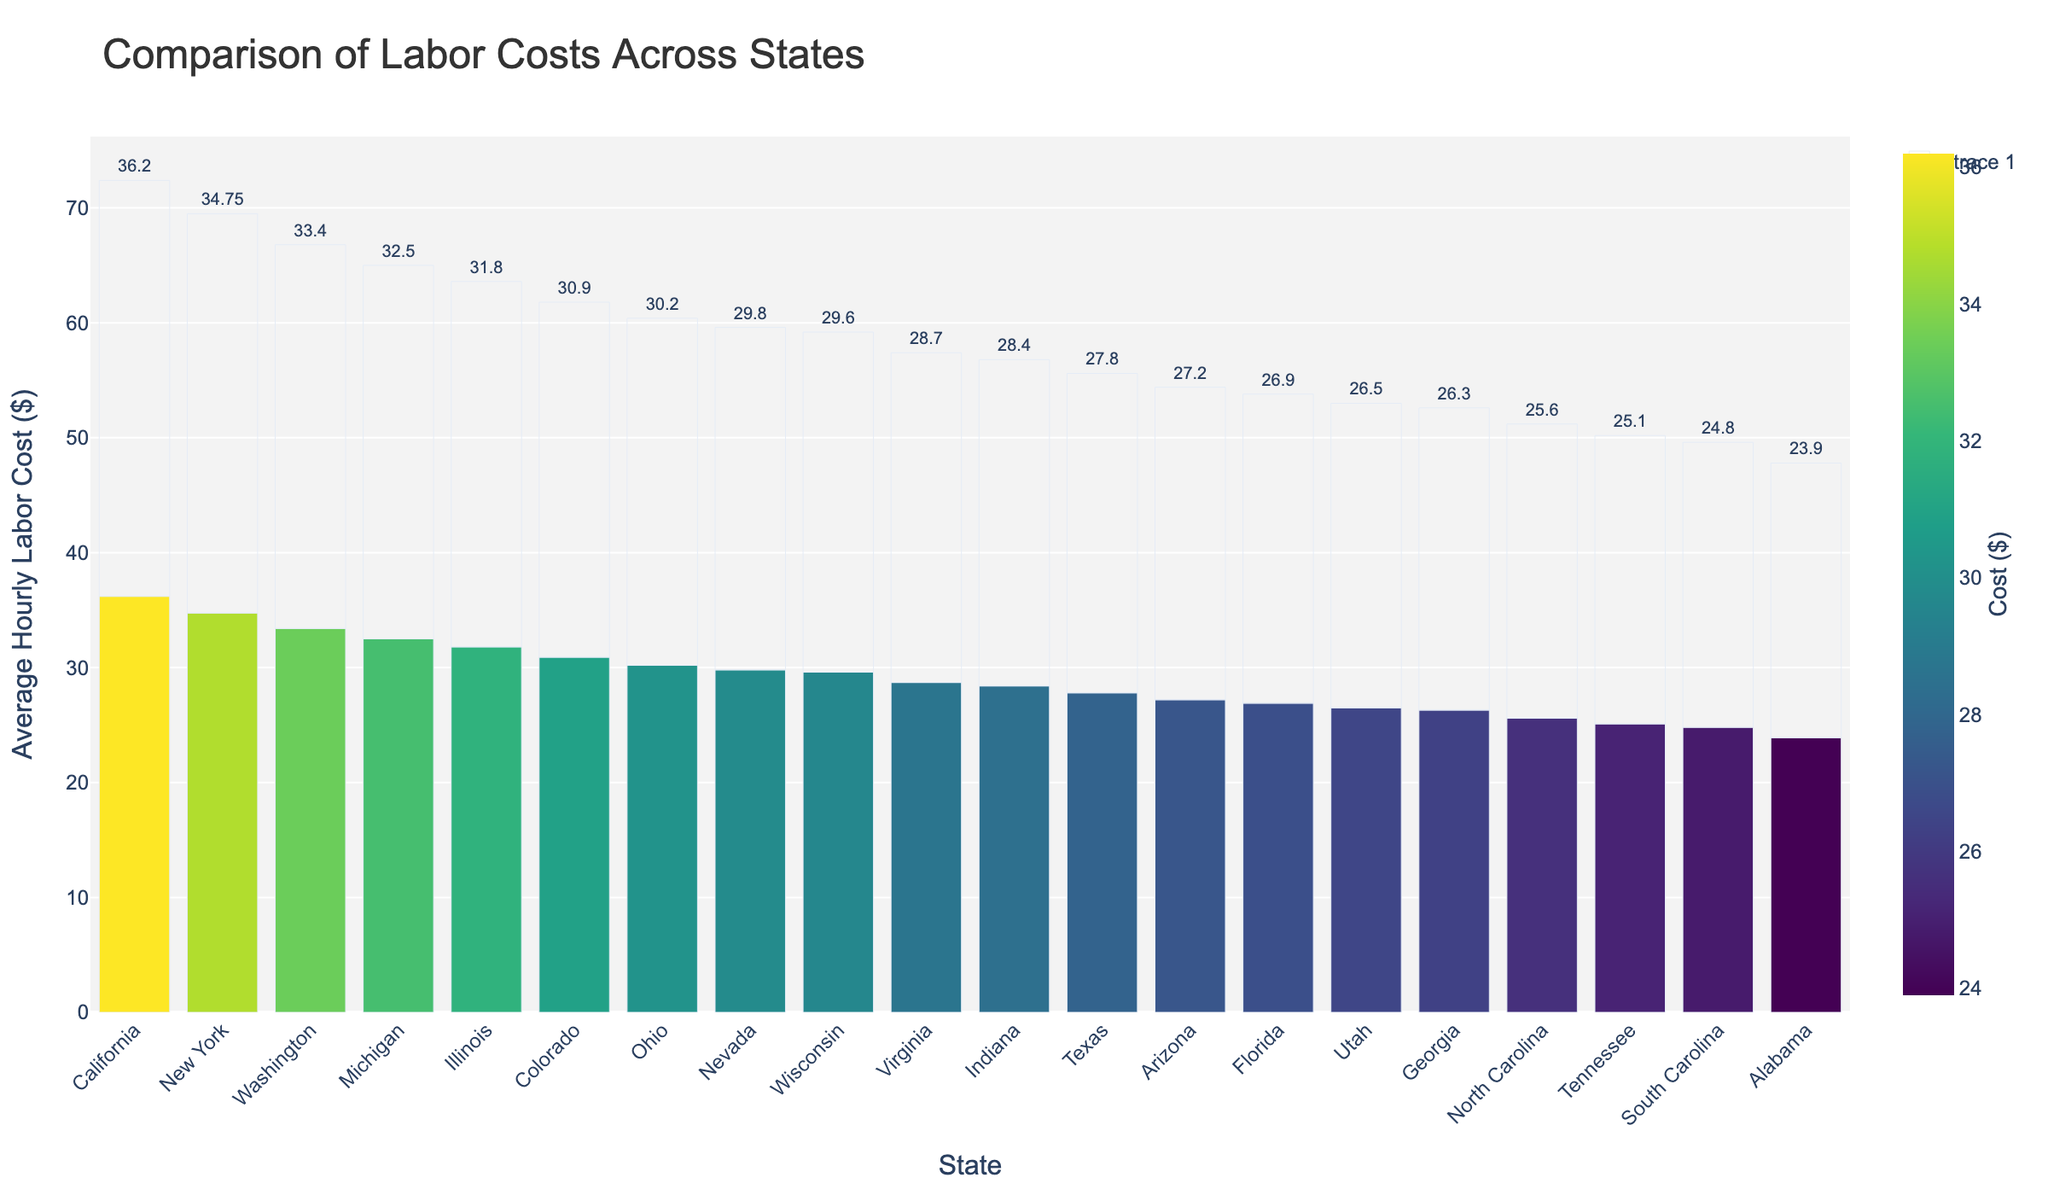What's the state with the highest average hourly labor cost, and what is the cost? By visually comparing the lengths of the bars, we can identify the bar representing the highest value. The state with the highest average hourly labor cost is California with $36.20.
Answer: California, $36.20 Which state has a lower average hourly labor cost, Texas or Florida? By locating both Texas and Florida on the chart and comparing their bar heights, it's clear that Florida has a lower average hourly labor cost of $26.90 compared to Texas' $27.80.
Answer: Florida What is the difference in average hourly labor cost between the highest and lowest states? The highest average hourly labor cost is California at $36.20, and the lowest is Alabama at $23.90. Subtracting these two values, $36.20 - $23.90 gives us $12.30.
Answer: $12.30 How does the average hourly labor cost of Michigan compare to New York? By comparing the heights of the bars for Michigan and New York, New York's bar is taller with $34.75 compared to Michigan's $32.50.
Answer: New York has a higher labor cost What's the combined average hourly labor cost of the three states with the lowest costs? The three states with the lowest costs are Alabama ($23.90), South Carolina ($24.80), and North Carolina ($25.60). Adding these together, $23.90 + $24.80 + $25.60 = $74.30.
Answer: $74.30 Which states have an average hourly labor cost greater than $30? By identifying the bars that are higher than the $30 mark, the states are Michigan ($32.50), New York ($34.75), California ($36.20), Illinois ($31.80), Wisconsin ($29.60 - actually below $30), Ohio ($30.20), Colorado ($30.90), and Washington ($33.40).
Answer: Michigan, New York, California, Illinois, Ohio, Colorado, Washington What is the mean average hourly labor cost for all states shown in the plot? Summing all average hourly labor costs (32.50, 34.75, 36.20, 27.80, 26.90, 25.60, 24.80, 23.90, 31.80, 28.40, 29.60, 30.20, 26.30, 25.10, 28.70, 27.20, 29.80, 26.50, 30.90, 33.40) and dividing by the number of states (20), the mean is (600.45/20) $30.02.
Answer: $30.02 Which state between Georgia and Tennessee has a higher average hourly labor cost, and by how much? Georgia's average is $26.30, and Tennessee's is $25.10. The difference is $26.30 - $25.10 = $1.20.
Answer: Georgia by $1.20 How many states have an average hourly labor cost between $28 and $32? By identifying the bars whose values fall between $28 and $32, the states are Michigan, Illinois, Indiana, Wisconsin, Ohio, Virginia, and Nevada, making a total of 7 states.
Answer: 7 states 